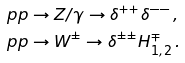Convert formula to latex. <formula><loc_0><loc_0><loc_500><loc_500>& p p \rightarrow Z / \gamma \rightarrow \delta ^ { + + } \delta ^ { - - } \, , \\ & p p \rightarrow W ^ { \pm } \rightarrow \delta ^ { \pm \pm } H _ { 1 , 2 } ^ { \mp } \, .</formula> 